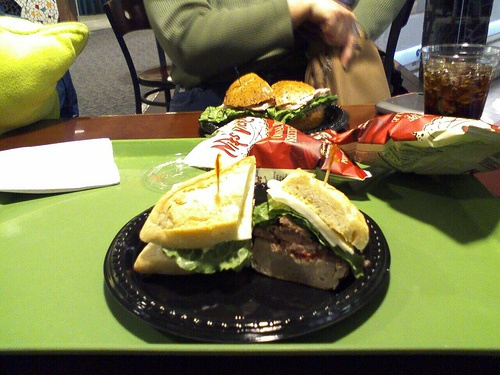Describe the objects in this image and their specific colors. I can see dining table in black, lightgreen, ivory, and olive tones, people in black, olive, gray, and darkgreen tones, sandwich in black, khaki, and olive tones, sandwich in black, ivory, and khaki tones, and cup in black, maroon, and gray tones in this image. 